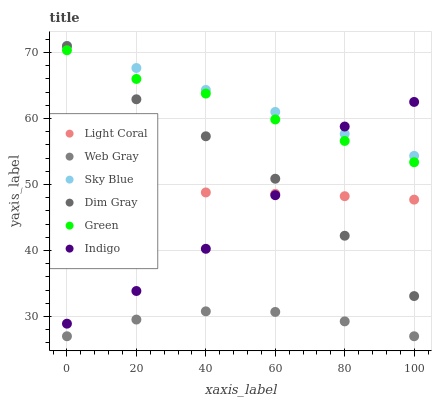Does Web Gray have the minimum area under the curve?
Answer yes or no. Yes. Does Sky Blue have the maximum area under the curve?
Answer yes or no. Yes. Does Indigo have the minimum area under the curve?
Answer yes or no. No. Does Indigo have the maximum area under the curve?
Answer yes or no. No. Is Sky Blue the smoothest?
Answer yes or no. Yes. Is Indigo the roughest?
Answer yes or no. Yes. Is Light Coral the smoothest?
Answer yes or no. No. Is Light Coral the roughest?
Answer yes or no. No. Does Web Gray have the lowest value?
Answer yes or no. Yes. Does Indigo have the lowest value?
Answer yes or no. No. Does Sky Blue have the highest value?
Answer yes or no. Yes. Does Indigo have the highest value?
Answer yes or no. No. Is Green less than Sky Blue?
Answer yes or no. Yes. Is Sky Blue greater than Green?
Answer yes or no. Yes. Does Dim Gray intersect Indigo?
Answer yes or no. Yes. Is Dim Gray less than Indigo?
Answer yes or no. No. Is Dim Gray greater than Indigo?
Answer yes or no. No. Does Green intersect Sky Blue?
Answer yes or no. No. 